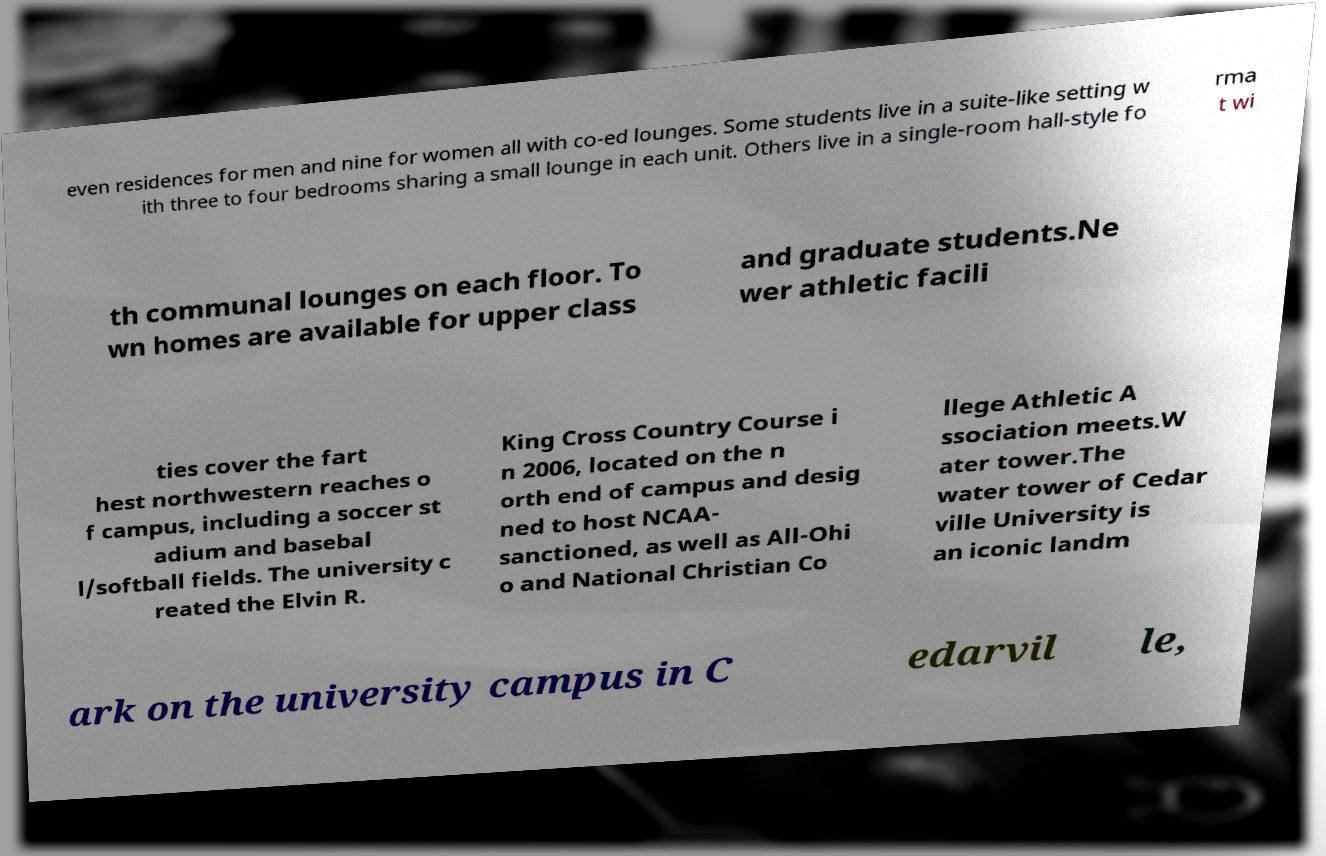Please read and relay the text visible in this image. What does it say? even residences for men and nine for women all with co-ed lounges. Some students live in a suite-like setting w ith three to four bedrooms sharing a small lounge in each unit. Others live in a single-room hall-style fo rma t wi th communal lounges on each floor. To wn homes are available for upper class and graduate students.Ne wer athletic facili ties cover the fart hest northwestern reaches o f campus, including a soccer st adium and basebal l/softball fields. The university c reated the Elvin R. King Cross Country Course i n 2006, located on the n orth end of campus and desig ned to host NCAA- sanctioned, as well as All-Ohi o and National Christian Co llege Athletic A ssociation meets.W ater tower.The water tower of Cedar ville University is an iconic landm ark on the university campus in C edarvil le, 